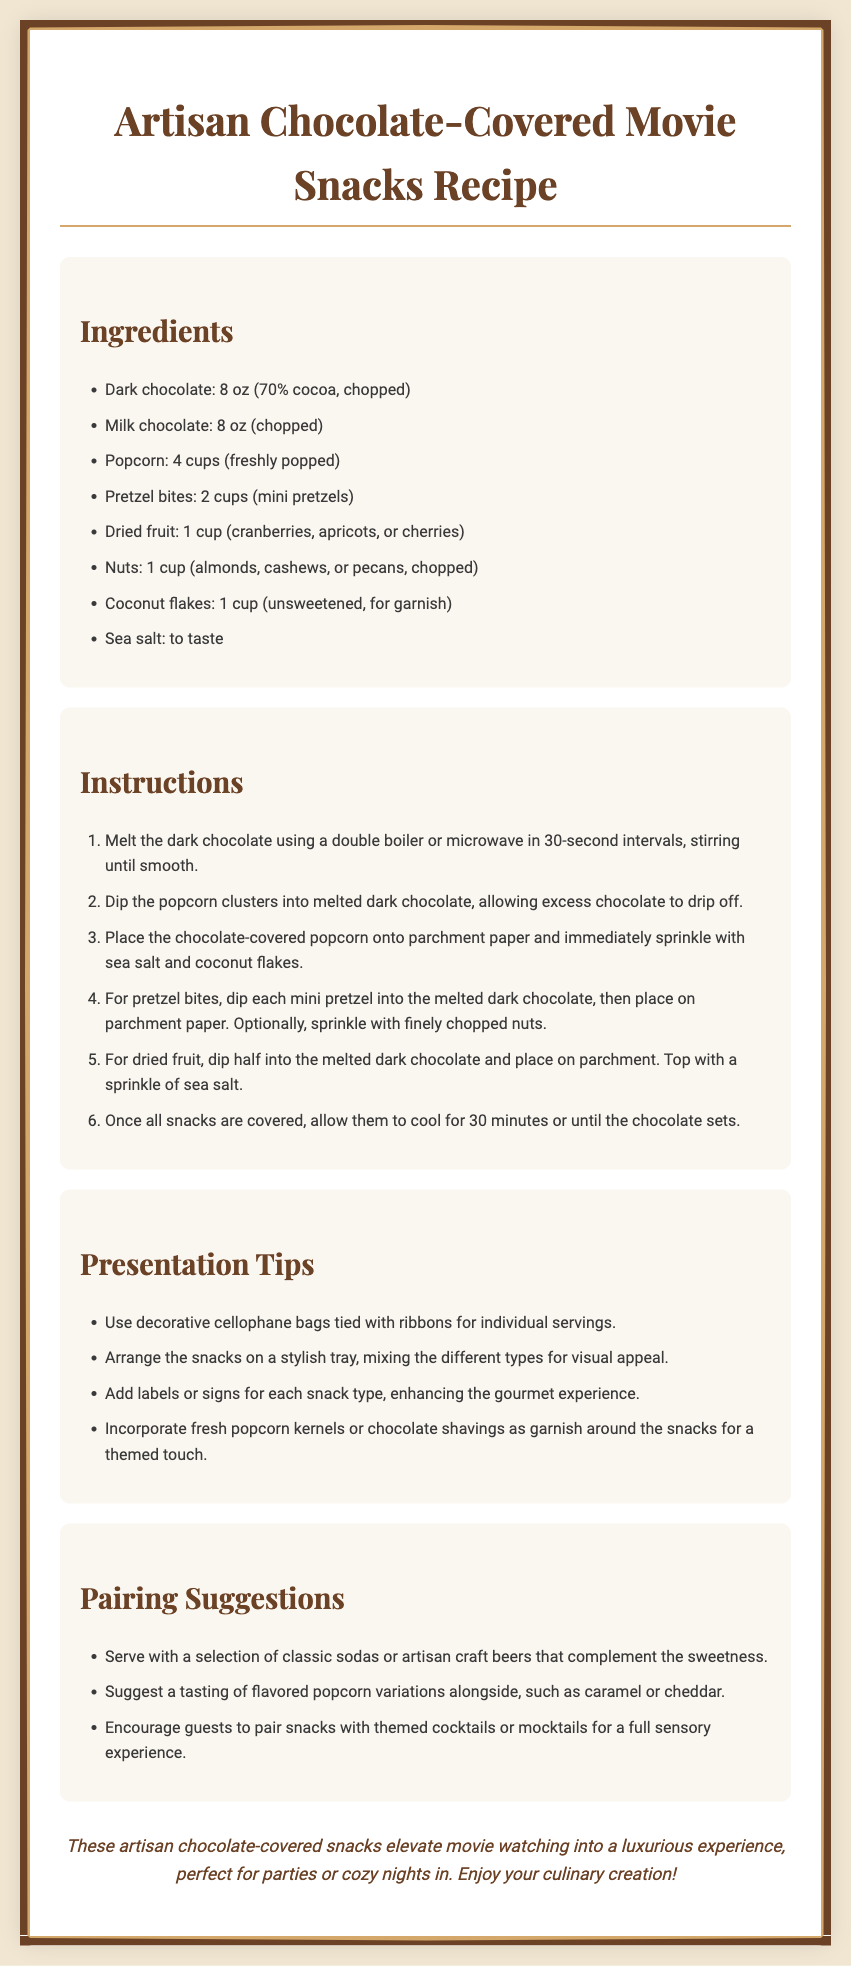What is the total amount of dark chocolate needed? The total amount of dark chocolate is specified in the ingredients section, which is 8 ounces.
Answer: 8 oz How many cups of popcorn are required? The ingredients list states that 4 cups of freshly popped popcorn are needed for the recipe.
Answer: 4 cups What type of garnish is suggested for the chocolate-covered snacks? The presentation tips mention using fresh popcorn kernels or chocolate shavings as garnish.
Answer: Fresh popcorn kernels or chocolate shavings What should be done right after dipping the popcorn in chocolate? After dipping, it is stated that excess chocolate should drip off before placing it on parchment paper and sprinkling it.
Answer: Allow excess chocolate to drip off What is a suggested pairing for the snacks? The pairing section includes classic sodas or artisan craft beers as suggested pairings.
Answer: Classic sodas or artisan craft beers What is the purpose of the decorative cellophane bags mentioned? The decorative cellophane bags are intended for individual servings of the snacks to enhance presentation.
Answer: Individual servings How long should the snacks cool after being covered in chocolate? The instructions specify that the snacks should cool for 30 minutes or until the chocolate sets.
Answer: 30 minutes What types of nuts can be used in the recipe? The ingredients list provides the options of almonds, cashews, or pecans for nuts.
Answer: Almonds, cashews, or pecans 